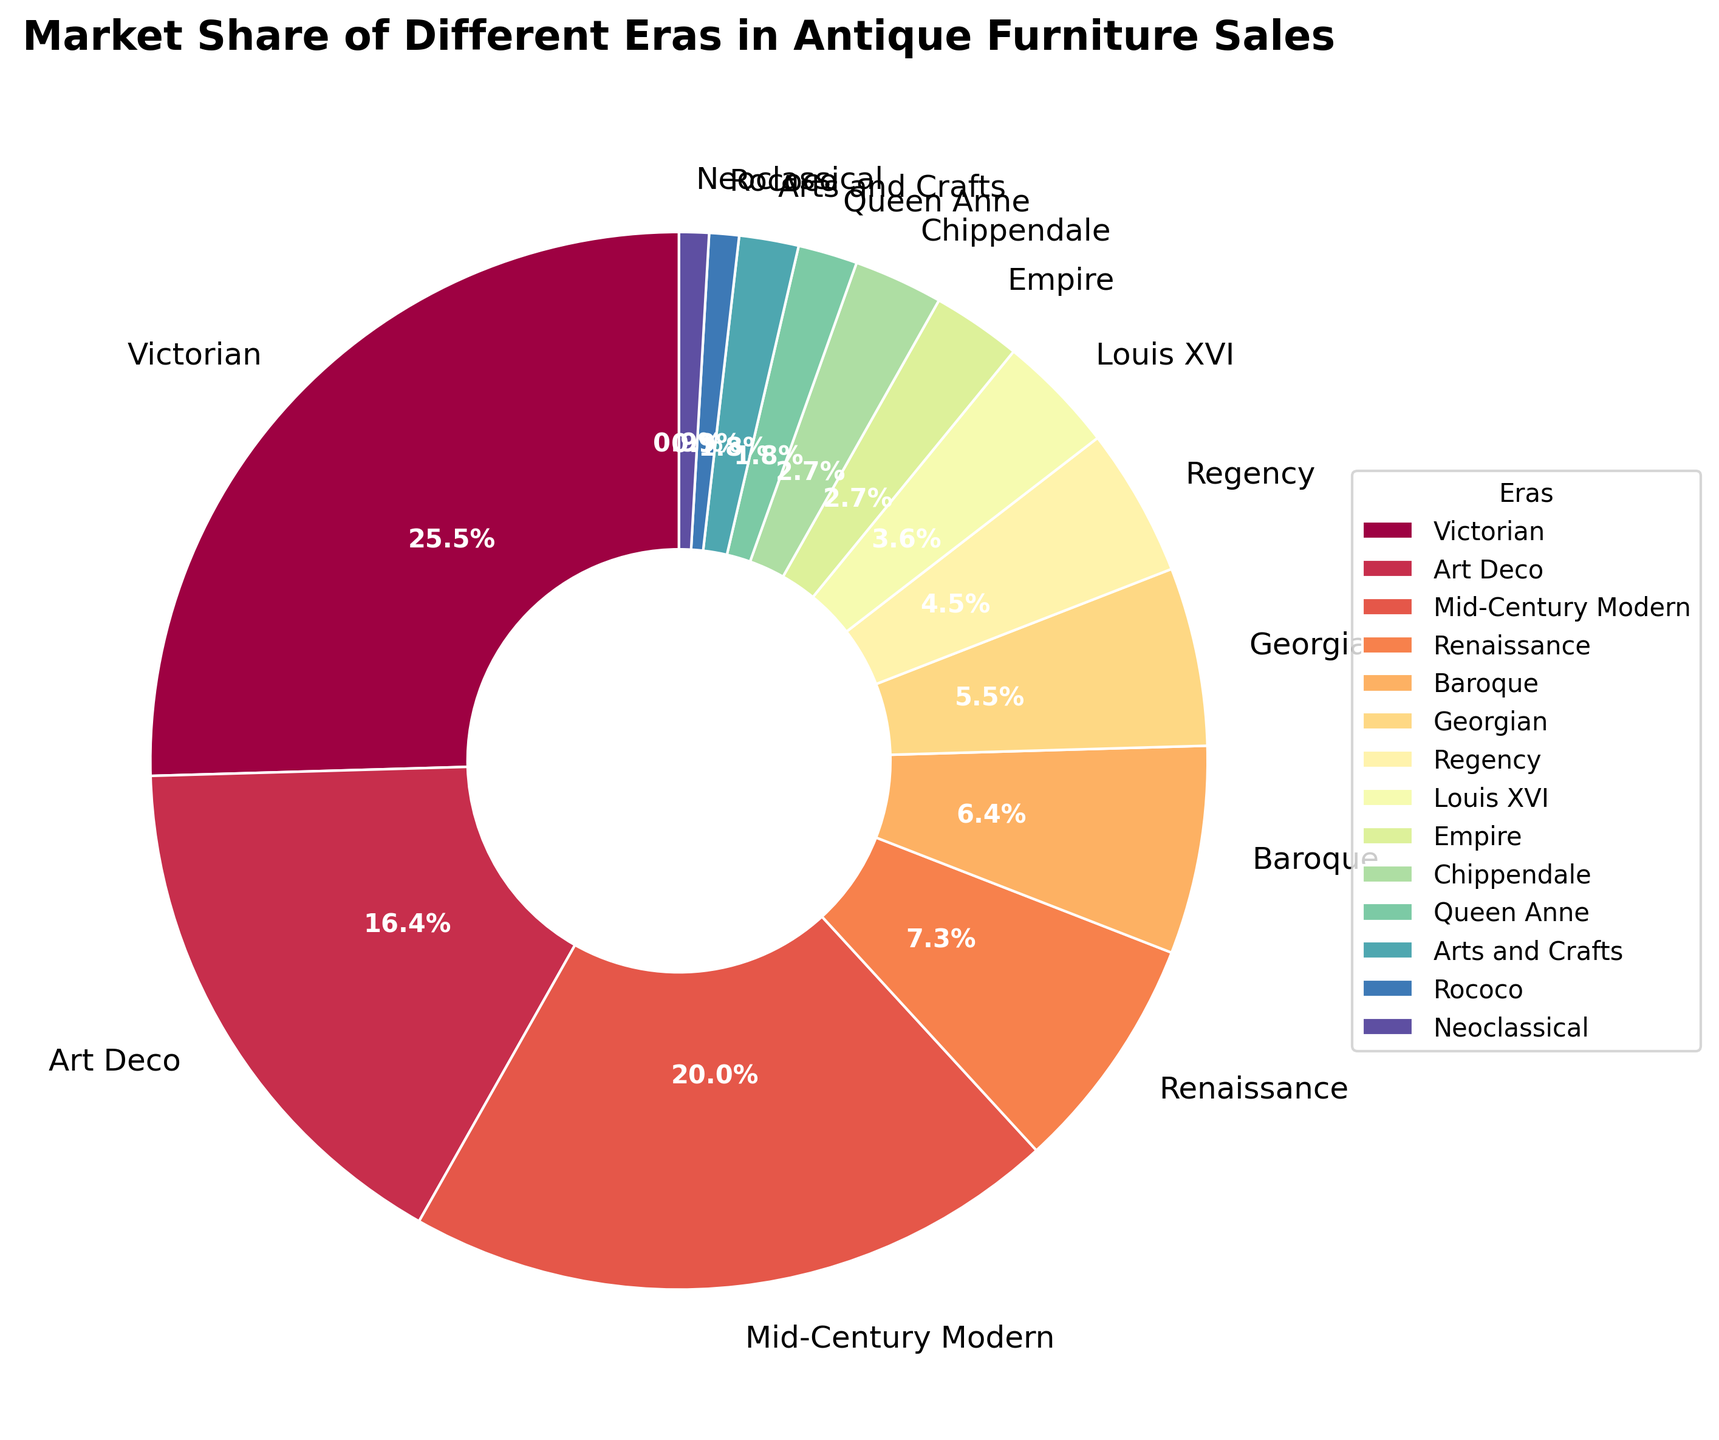Which era has the largest market share in antique furniture sales? The largest segment in the pie chart represents the Victorian era, which comprises 28% of the market share.
Answer: Victorian What is the combined market share of Victorian and Mid-Century Modern eras? The Victorian era has a 28% market share, and Mid-Century Modern has a 22% market share. The combined market share is 28% + 22% = 50%.
Answer: 50% How does the market share of Art Deco compare to Regency? The market share of Art Deco is 18%, while that of Regency is 5%. Art Deco has a larger share than Regency.
Answer: Art Deco > Regency Which three eras have the smallest market shares and what are their percentages? The smallest segments in the pie chart are Rococo (1%), Neoclassical (1%), and Queen Anne/Arts and Crafts each (2%).
Answer: Rococo (1%), Neoclassical (1%), Queen Anne/Arts and Crafts (2%) What is the total market share of all eras with less than 5% individually? The eras with less than 5% market share are Rococo (1%), Neoclassical (1%), Queen Anne (2%), Arts and Crafts (2%), Empire (3%), Chippendale (3%), Louis XVI (4%), and Regency (5%). The total market share is 1% + 1% + 2% + 2% + 3% + 3% + 4% + 5% = 21%.
Answer: 21% How much more market share does the Victorian era have compared to the Georgian era? The Victorian era has a 28% market share, while the Georgian era has a 6% market share. The difference is 28% - 6% = 22%.
Answer: 22% What is the difference in market share between Baroque and Empire eras? Baroque has a 7% market share, and Empire has a 3% market share. The difference is 7% - 3% = 4%.
Answer: 4% Which era has an equal market share to Chippendale? The pie chart shows that the Chippendale era and the Empire era have the same market share of 3%.
Answer: Empire What is the visual attribute of the era with the least market share? The era with the least market share is Rococo, which is represented by the smallest segment in the pie chart.
Answer: Rococo Which era is represented by the orange color in the pie chart? Without the actual color mapping information, we cannot determine the specific era represented by the orange color.
Answer: Not determined 